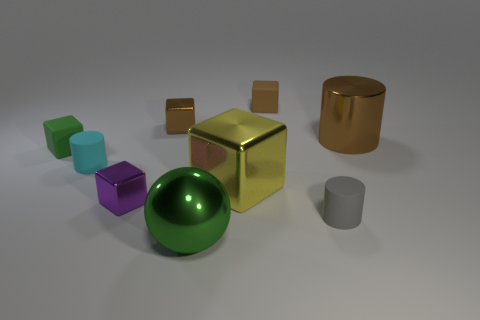Subtract 1 cylinders. How many cylinders are left? 2 Subtract all green balls. How many brown blocks are left? 2 Subtract all small purple cubes. How many cubes are left? 4 Subtract all purple blocks. How many blocks are left? 4 Subtract all gray blocks. Subtract all blue spheres. How many blocks are left? 5 Add 1 large yellow objects. How many objects exist? 10 Subtract all spheres. How many objects are left? 8 Subtract 0 red blocks. How many objects are left? 9 Subtract all big yellow metallic blocks. Subtract all large green balls. How many objects are left? 7 Add 9 brown shiny cylinders. How many brown shiny cylinders are left? 10 